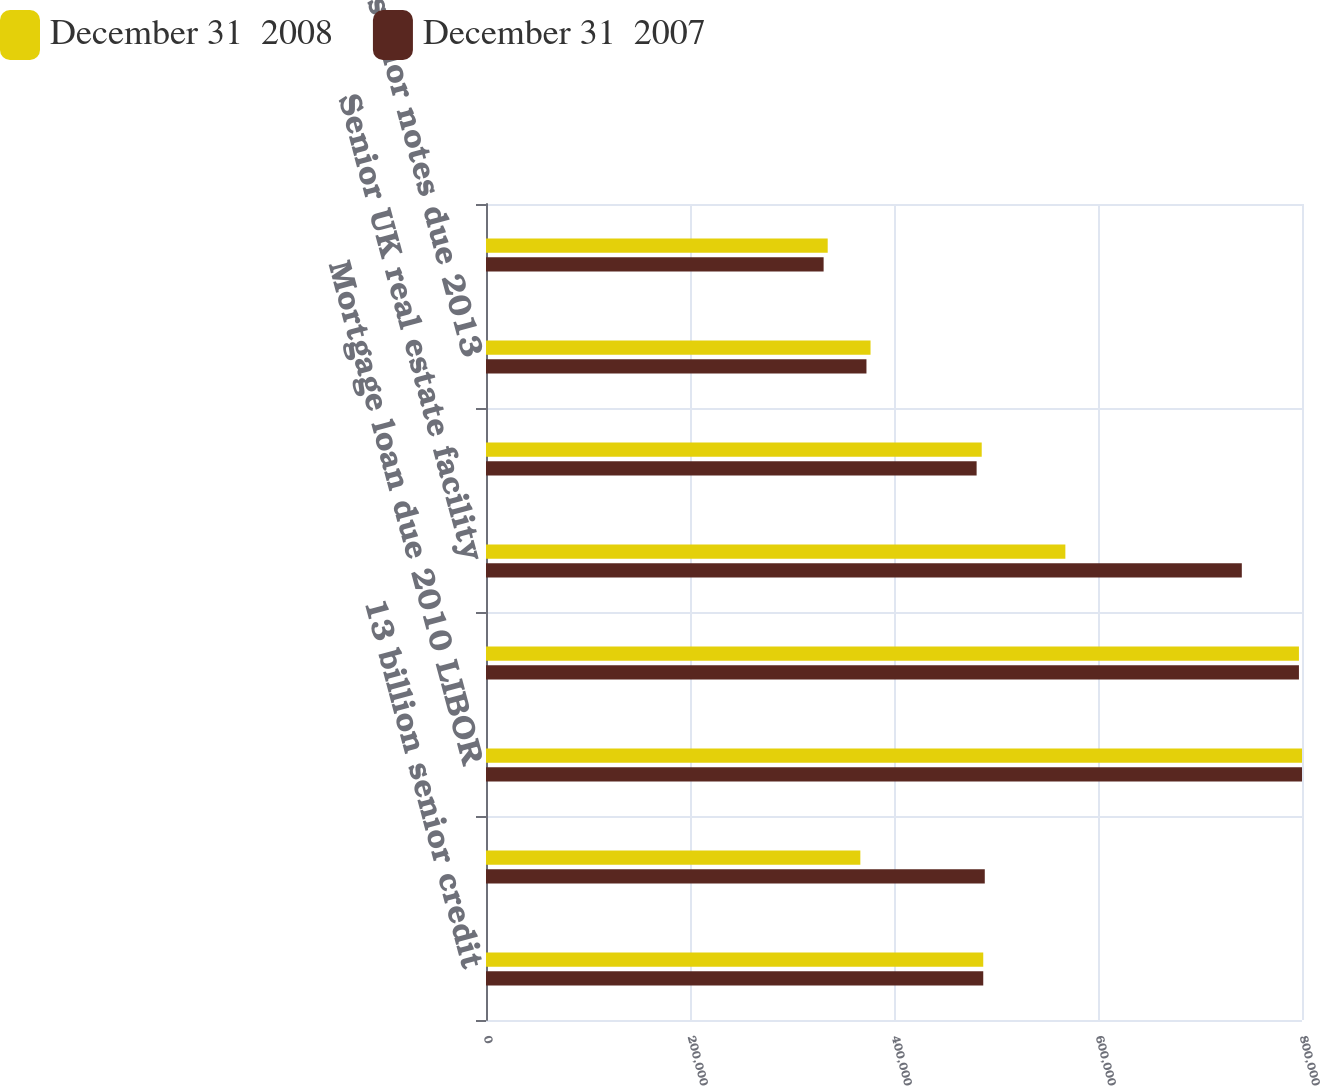Convert chart to OTSL. <chart><loc_0><loc_0><loc_500><loc_500><stacked_bar_chart><ecel><fcel>13 billion senior credit<fcel>20 billion credit facility due<fcel>Mortgage loan due 2010 LIBOR<fcel>804 million secured term loan<fcel>Senior UK real estate facility<fcel>7625 bonds due 2011 (Face<fcel>7875 senior notes due 2013<fcel>7375 senior notes due 2018<nl><fcel>December 31  2008<fcel>487500<fcel>367000<fcel>800000<fcel>797000<fcel>568000<fcel>486000<fcel>377000<fcel>335000<nl><fcel>December 31  2007<fcel>487500<fcel>489000<fcel>800000<fcel>797000<fcel>741000<fcel>481000<fcel>373000<fcel>331000<nl></chart> 